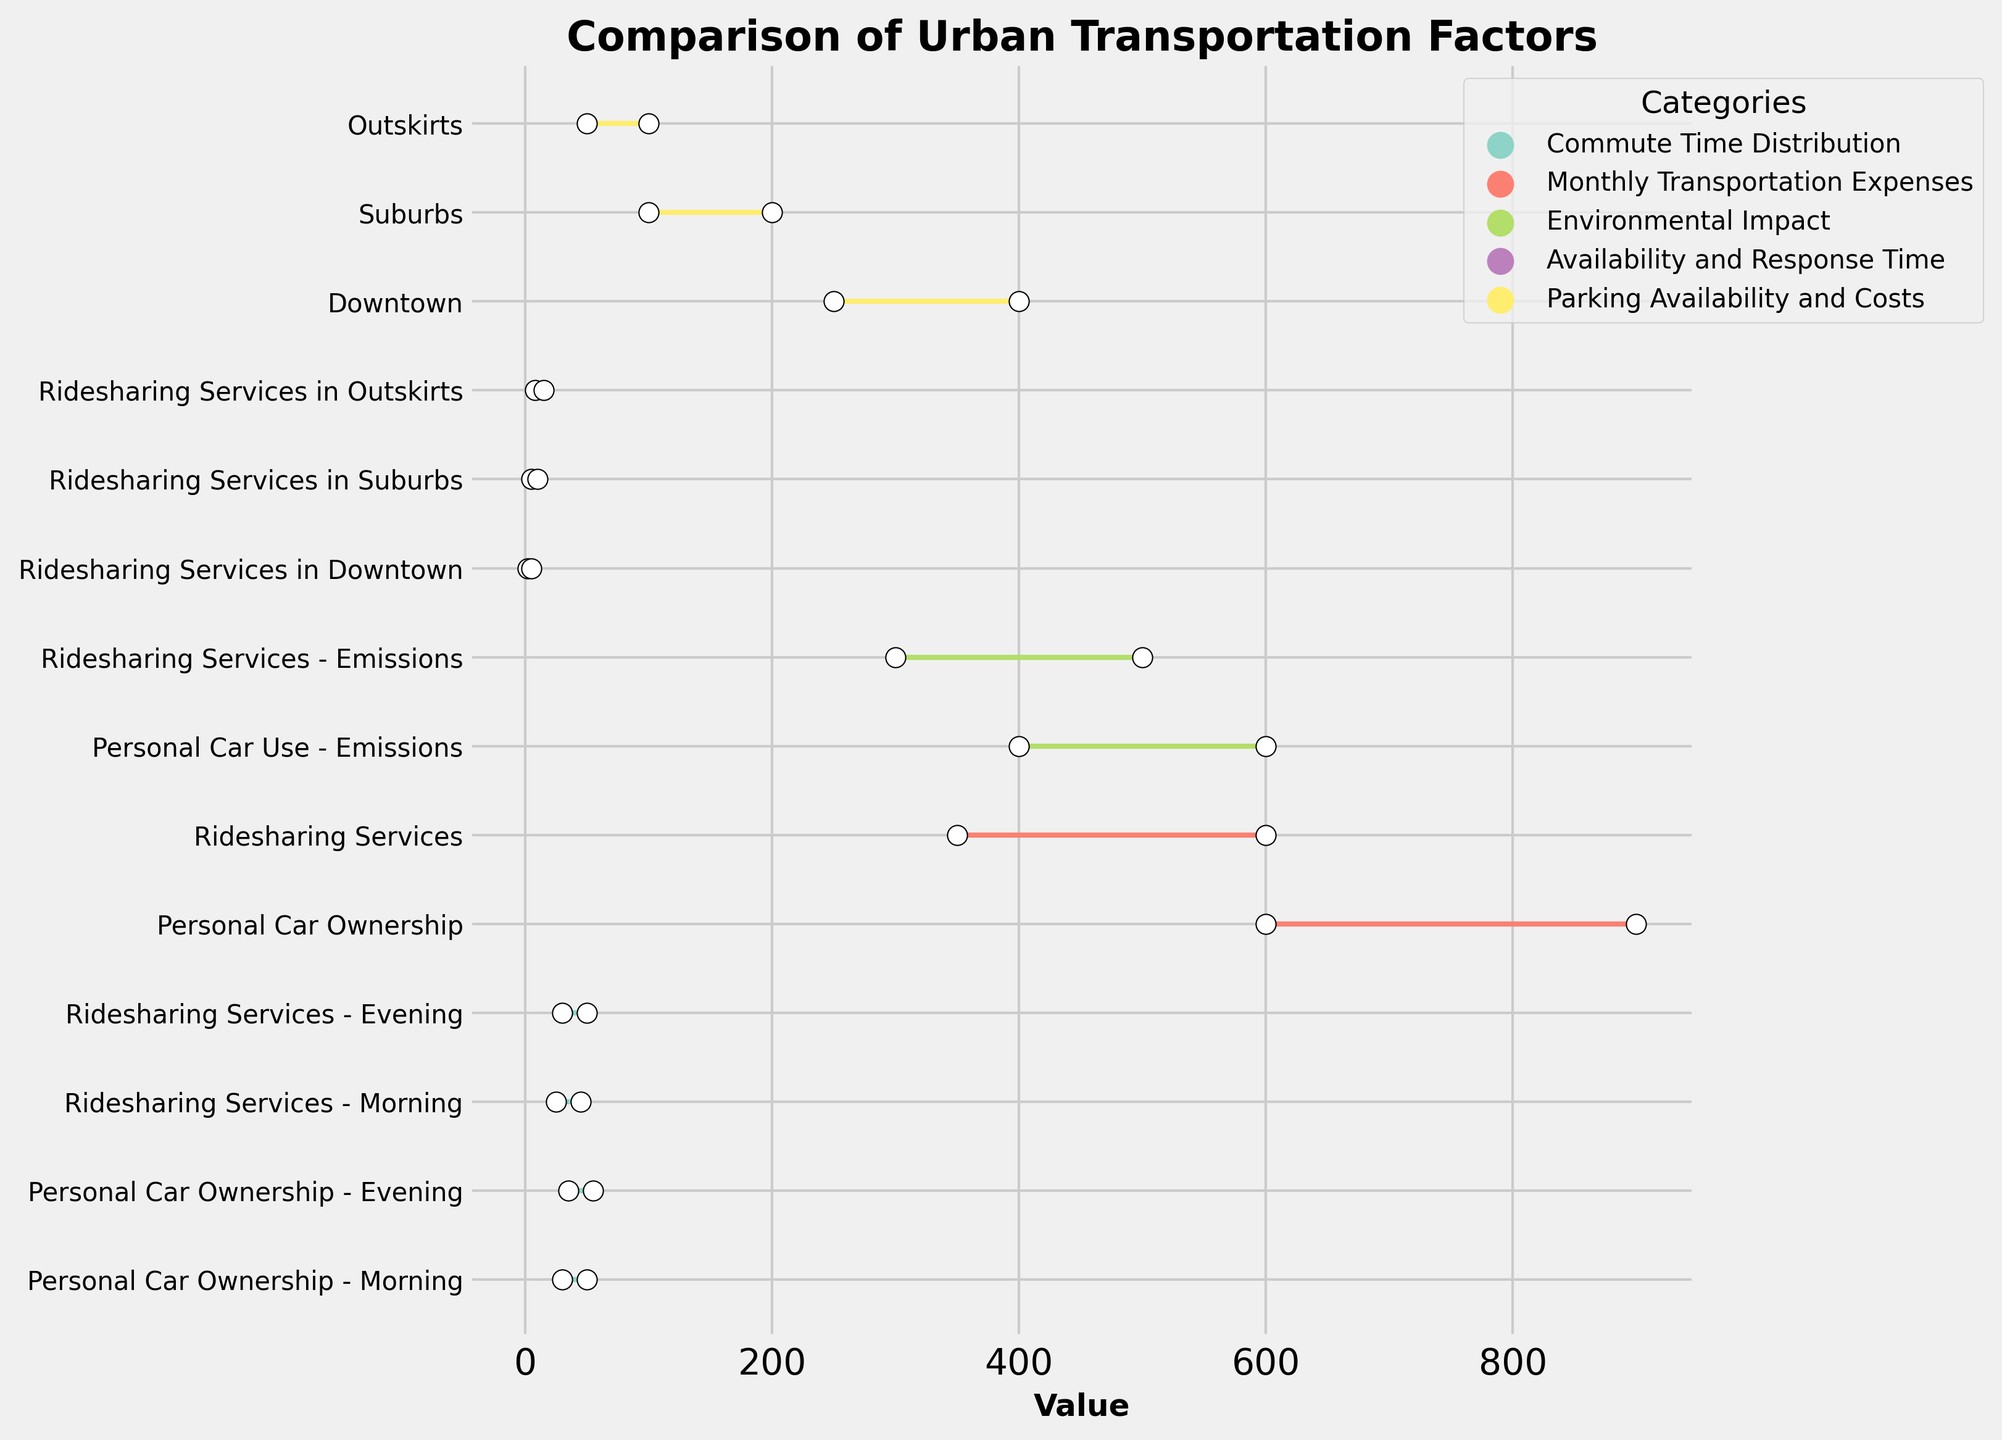What's the maximum commute time for ridesharing services in the evening? The upper bound for commute time using ridesharing services in the evening is shown in the figure as 50 minutes.
Answer: 50 minutes How do the upper bounds for emissions compare between personal car use and ridesharing services? The upper bound for emissions using a personal car is 600 grams CO2/mile, while for ridesharing services, it is 500 grams CO2/mile. Therefore, the upper bound for emissions is higher for personal car use.
Answer: Personal car use What's the range of monthly transportation expenses for personal car ownership? The lower bound is 600 USD, and the upper bound is 900 USD, so the range is calculated as 900 - 600 = 300 USD.
Answer: 300 USD Which category has a larger range for commute times in the morning, personal car ownership or ridesharing services? The range for personal car ownership in the morning is 50 - 30 = 20 minutes. The range for ridesharing services in the morning is 45 - 25 = 20 minutes. Both categories have the same range of 20 minutes.
Answer: Both have the same range What's the shortest response time for ridesharing services in downtown? The lower bound for response time in downtown is shown as 2 minutes.
Answer: 2 minutes Compare the parking costs range between downtown and suburbs. For downtown, the range of parking costs is 400 - 250 = 150 USD. For suburbs, the range is 200 - 100 = 100 USD. Therefore, downtown has a larger range of parking costs.
Answer: Downtown How does the commute time range in the evening compare between personal car ownership and ridesharing services? The range for personal car ownership in the evening is 55 - 35 = 20 minutes. The range for ridesharing in the evening is 50 - 30 = 20 minutes. They both have a commute time range of 20 minutes.
Answer: Same range What's the longest response time for ridesharing services in the outskirts? The upper bound for response time in the outskirts is shown as 15 minutes.
Answer: 15 minutes Compare the median values of emissions between personal car use and ridesharing services. The median value is halfway between the lower and upper bounds. For personal car use, it's (400+600)/2 = 500 grams CO2/mile. For ridesharing, it's (300+500)/2 = 400 grams CO2/mile. So, personal car use has a higher median emissions value.
Answer: Personal car use 